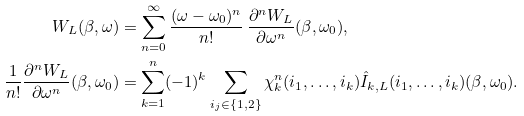<formula> <loc_0><loc_0><loc_500><loc_500>W _ { L } ( \beta , \omega ) & = \sum _ { n = 0 } ^ { \infty } \frac { ( \omega - \omega _ { 0 } ) ^ { n } } { n ! } \, \frac { \partial ^ { n } W _ { L } } { \partial \omega ^ { n } } ( \beta , \omega _ { 0 } ) , \\ \frac { 1 } { n ! } \frac { \partial ^ { n } W _ { L } } { \partial \omega ^ { n } } ( \beta , \omega _ { 0 } ) & = \sum _ { k = 1 } ^ { n } ( - 1 ) ^ { k } \sum _ { i _ { j } \in \{ 1 , 2 \} } \chi _ { k } ^ { n } ( i _ { 1 } , \dots , i _ { k } ) { \hat { I } } _ { k , L } ( i _ { 1 } , \dots , i _ { k } ) ( \beta , \omega _ { 0 } ) .</formula> 